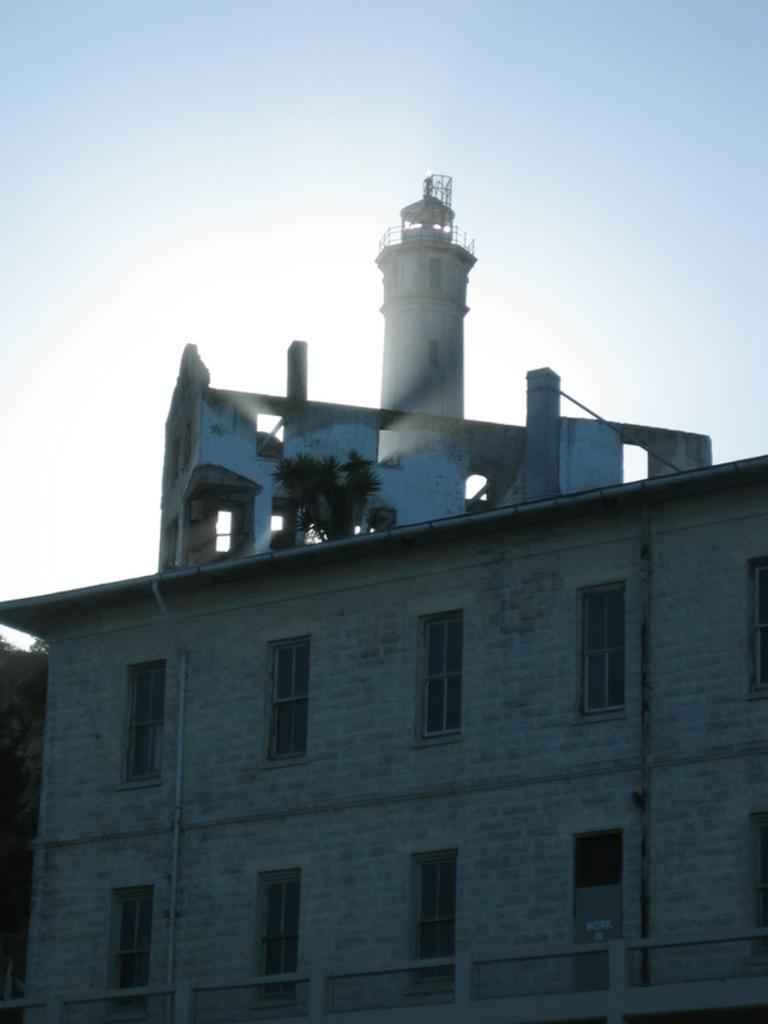What type of structure is present in the image? There is a building in the image. What feature of the building is mentioned in the facts? The building has many windows and a tower at the top. What can be seen in the background of the image? The sky is visible in the image. What flavor of record can be seen on the windowsill in the image? There is no record or flavor mentioned in the image; it features a building with windows and a tower. 